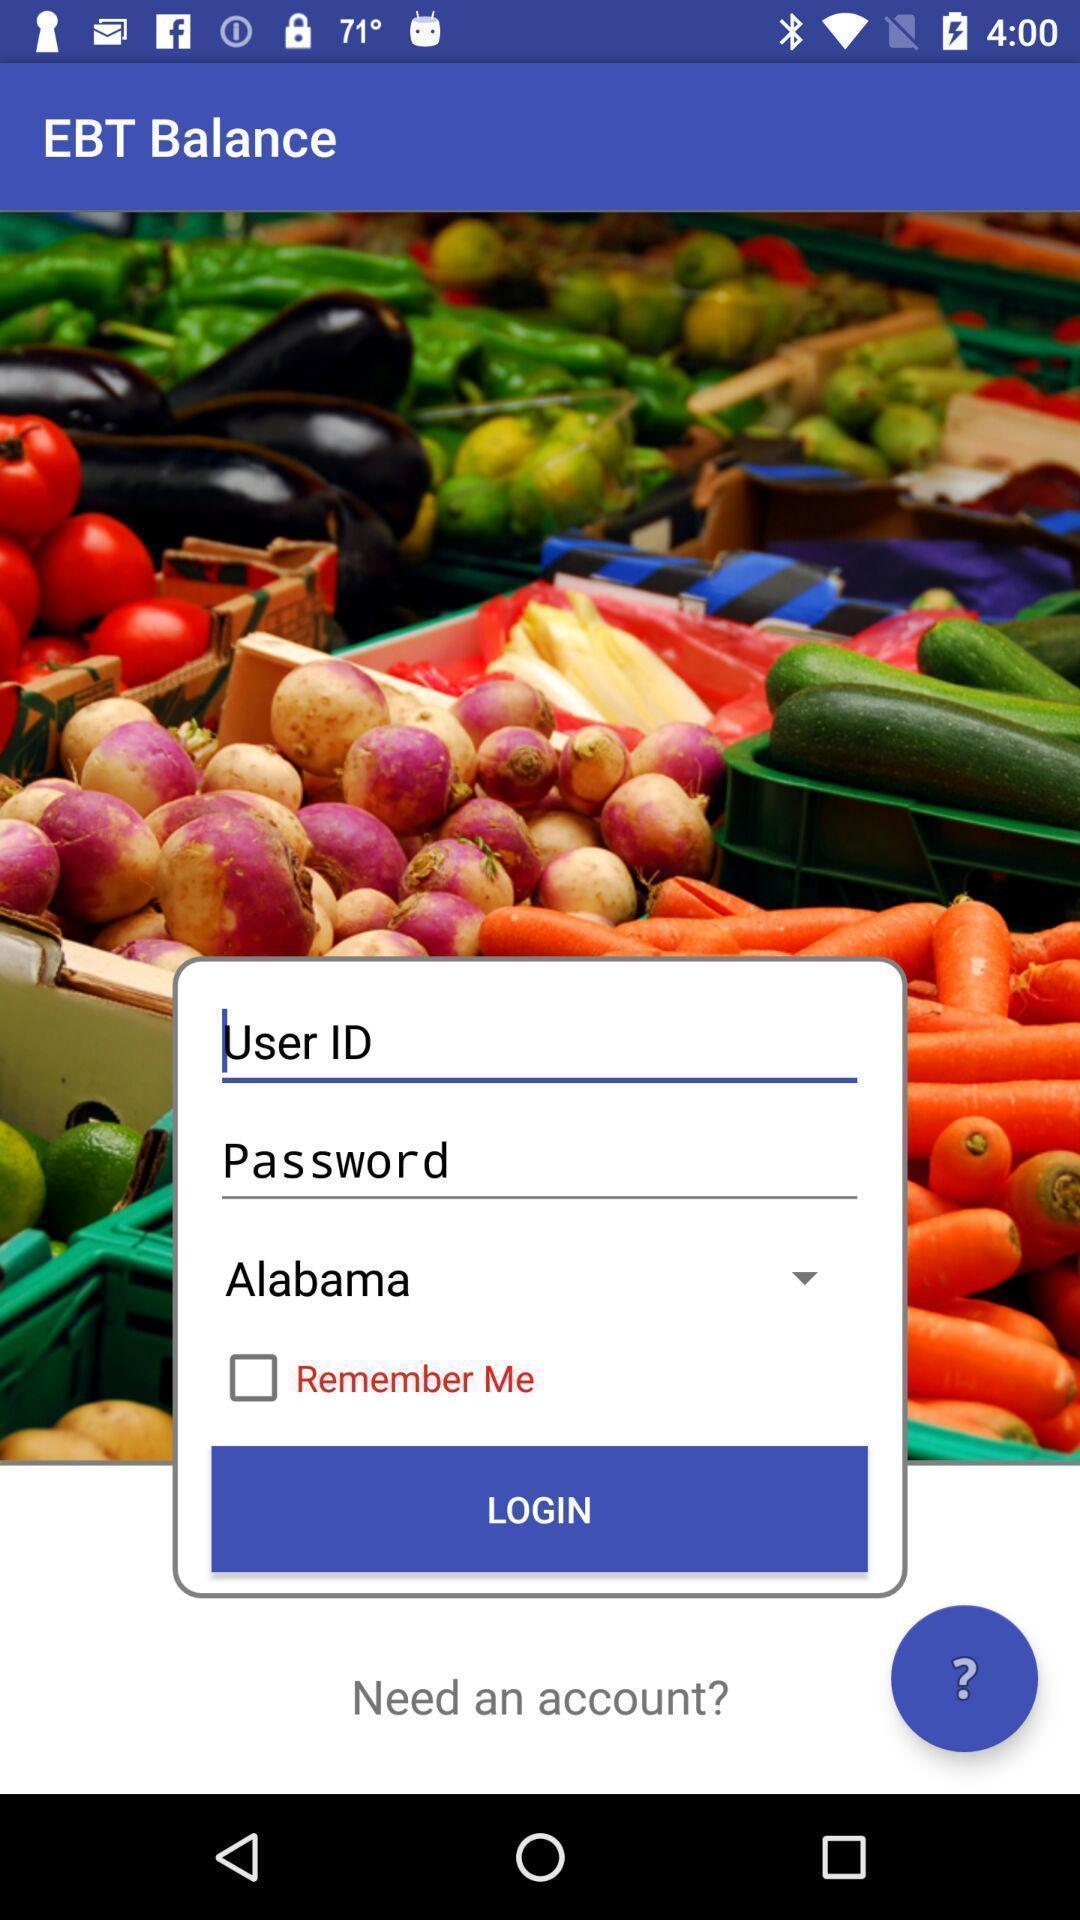Please provide a description for this image. Screen displaying multiple options in login page. 